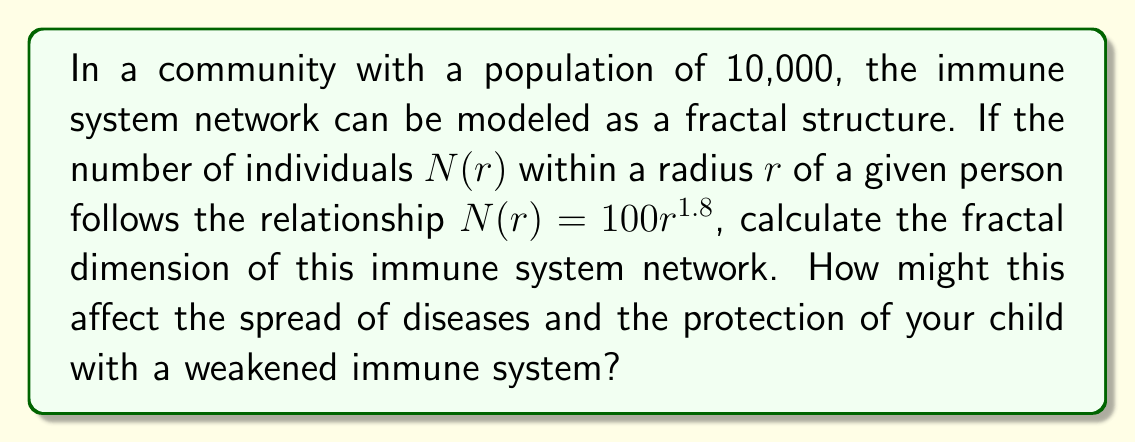Provide a solution to this math problem. To calculate the fractal dimension of the immune system network, we'll use the box-counting method, which is related to the power-law relationship between $N(r)$ and $r$.

1. The general form of the relationship is:
   $$N(r) = kr^D$$
   where $k$ is a constant and $D$ is the fractal dimension.

2. In our case, we have:
   $$N(r) = 100r^{1.8}$$

3. Comparing this to the general form, we can see that:
   $k = 100$
   $D = 1.8$

4. Therefore, the fractal dimension of this immune system network is 1.8.

5. Interpretation for the given persona:
   - A fractal dimension of 1.8 indicates a complex, interconnected network that's more dense than a simple line (dimension 1) but less dense than a filled plane (dimension 2).
   - This suggests that the immune system network in the community has a high degree of connectivity, which can be beneficial for herd immunity.
   - For a child with a weakened immune system, this higher fractal dimension implies:
     a) Potentially faster disease spread due to increased connectivity.
     b) But also potentially stronger herd immunity effects, as the network can more efficiently distribute immunity information.
   - The parent should be aware that while this network structure can provide good protection through herd immunity, it also means that any breach in the immunity could spread quickly.
Answer: $D = 1.8$ 